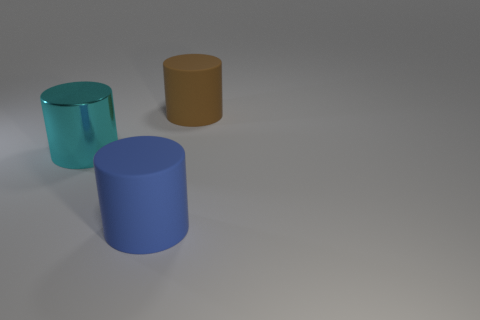Is the number of brown matte cylinders greater than the number of brown metal cubes?
Offer a terse response. Yes. Is the blue cylinder made of the same material as the large brown cylinder?
Make the answer very short. Yes. Is the number of large metallic cylinders less than the number of blue balls?
Your answer should be very brief. No. There is a object that is right of the cyan shiny cylinder and to the left of the large brown thing; what is its material?
Make the answer very short. Rubber. What size is the matte cylinder that is right of the big matte object on the left side of the object that is behind the large cyan metal cylinder?
Make the answer very short. Large. Is the shape of the big brown matte object the same as the object that is on the left side of the large blue rubber cylinder?
Ensure brevity in your answer.  Yes. What number of large cylinders are both behind the big cyan metallic cylinder and to the left of the large blue object?
Ensure brevity in your answer.  0. What number of gray objects are metal cylinders or matte objects?
Offer a very short reply. 0. There is a large rubber cylinder behind the blue matte thing; does it have the same color as the big object in front of the big metal object?
Offer a terse response. No. What is the color of the matte cylinder that is to the left of the large thing right of the matte thing that is in front of the large brown cylinder?
Keep it short and to the point. Blue. 